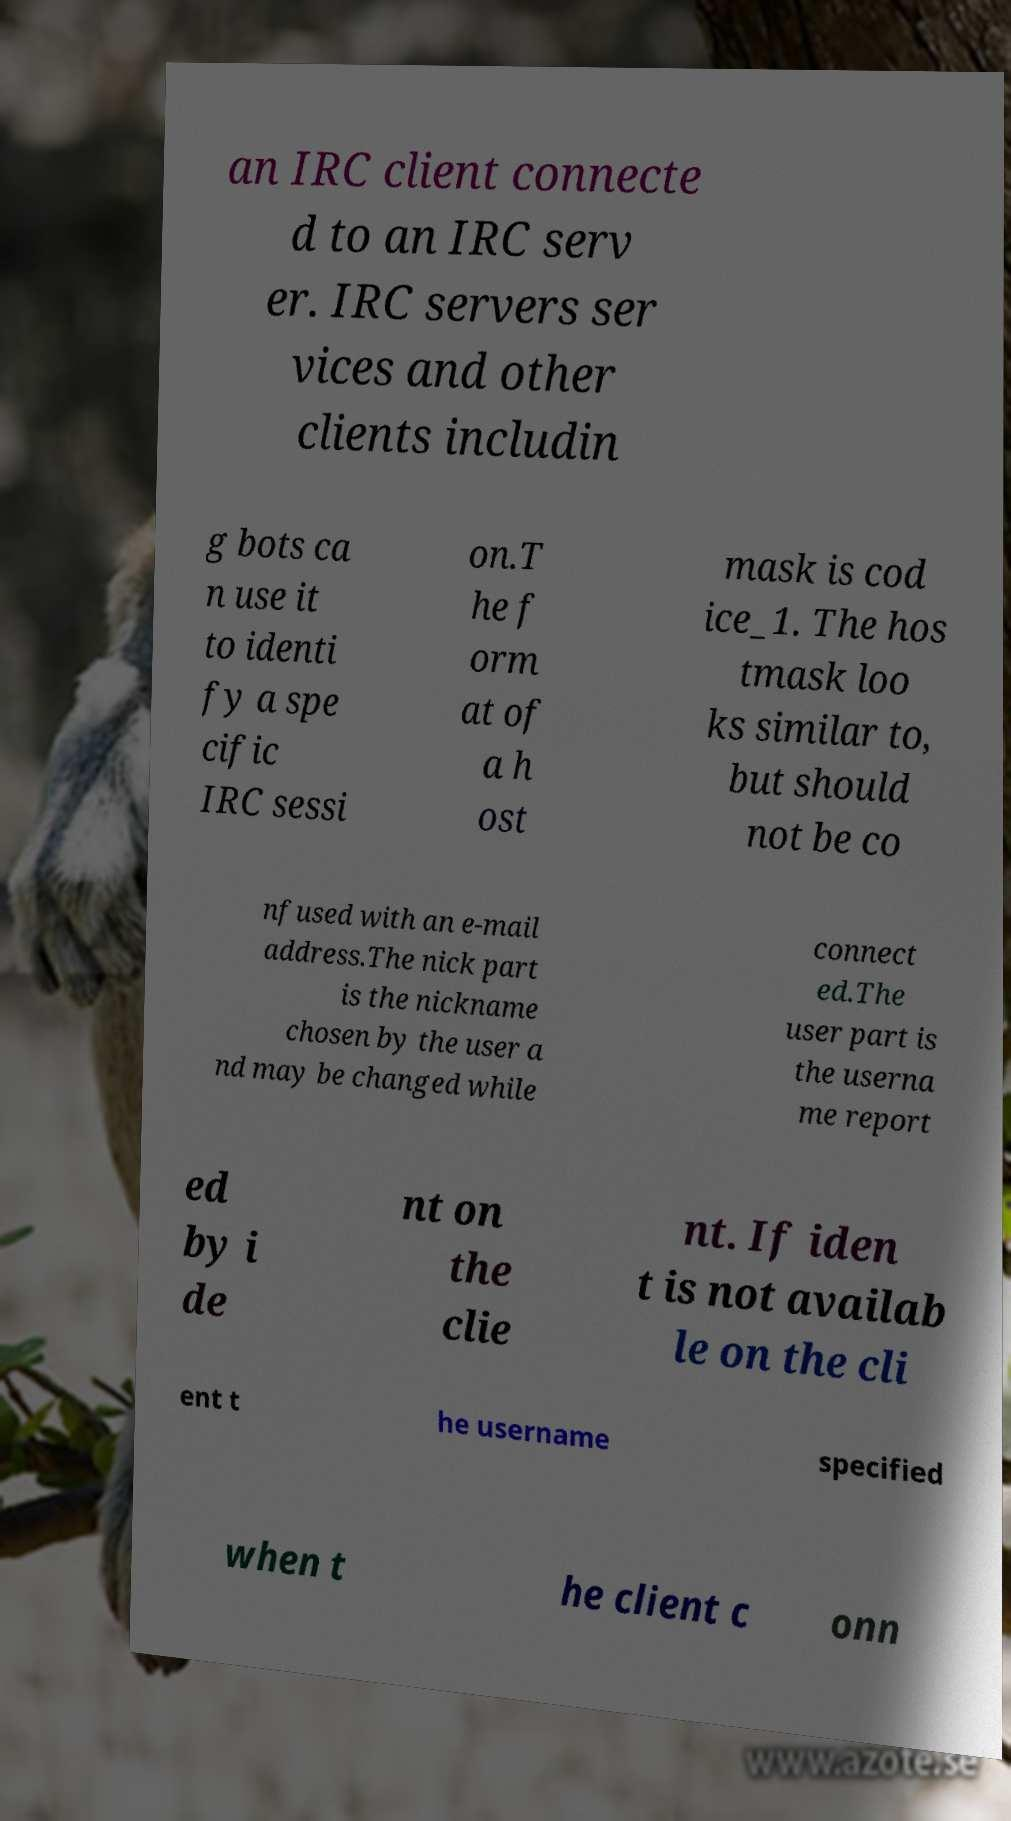For documentation purposes, I need the text within this image transcribed. Could you provide that? an IRC client connecte d to an IRC serv er. IRC servers ser vices and other clients includin g bots ca n use it to identi fy a spe cific IRC sessi on.T he f orm at of a h ost mask is cod ice_1. The hos tmask loo ks similar to, but should not be co nfused with an e-mail address.The nick part is the nickname chosen by the user a nd may be changed while connect ed.The user part is the userna me report ed by i de nt on the clie nt. If iden t is not availab le on the cli ent t he username specified when t he client c onn 